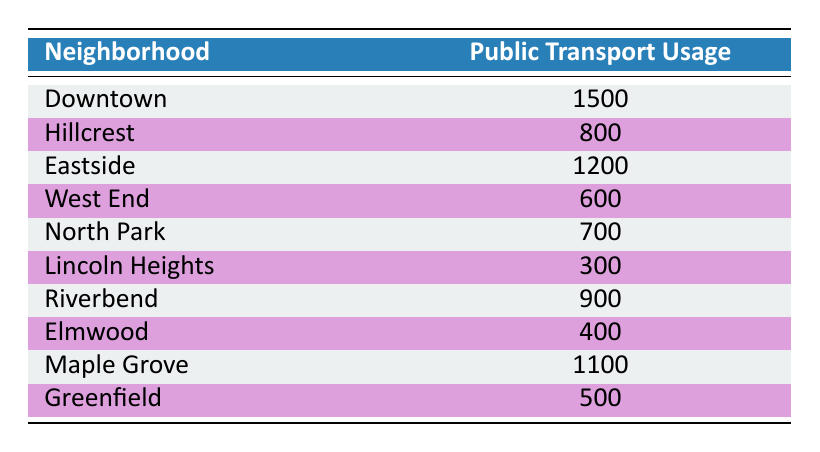What neighborhood has the highest public transport usage? From the table, Downtown has a public transport usage of 1500, which is the highest value compared to other neighborhoods.
Answer: Downtown How many neighborhoods have a public transport usage below 800? Based on the table, Lincoln Heights (300), West End (600), Elmwood (400), and Greenfield (500) have public transport usage below 800. This totals to 4 neighborhoods.
Answer: 4 What is the difference in public transport usage between the neighborhood with the highest usage and the neighborhood with the lowest usage? Downtown has the highest usage at 1500 and Lincoln Heights has the lowest usage at 300. The difference is 1500 - 300 = 1200.
Answer: 1200 What is the average public transport usage across all neighborhoods? First, sum all public transport usages: (1500 + 800 + 1200 + 600 + 700 + 300 + 900 + 400 + 1100 + 500) = 7100. There are 10 neighborhoods, so the average is 7100 / 10 = 710.
Answer: 710 Is there any neighborhood with a public transport usage of exactly 800? The table shows that Hillcrest has a public transport usage of 800. Therefore, the answer is yes.
Answer: Yes Which neighborhood has the second-highest public transport usage? After Downtown (1500), the next highest public transport usage is by Eastside with 1200.
Answer: Eastside How many neighborhoods have a public transport usage over 1000? The neighborhoods with usage over 1000 are Downtown (1500), Eastside (1200), and Maple Grove (1100). This means there are 3 neighborhoods that meet this criterion.
Answer: 3 What is the sum of public transport usage for neighborhoods in the lower half of usage? The neighborhoods in the lower half based on usage are Lincoln Heights (300), West End (600), North Park (700), Elmwood (400), and Greenfield (500). Their total usage is 300 + 600 + 700 + 400 + 500 = 2500.
Answer: 2500 Is the public transport usage of Maple Grove greater than the average usage? The average public transport usage is 710, and Maple Grove has a usage of 1100. Since 1100 is greater than 710, the answer is yes.
Answer: Yes 